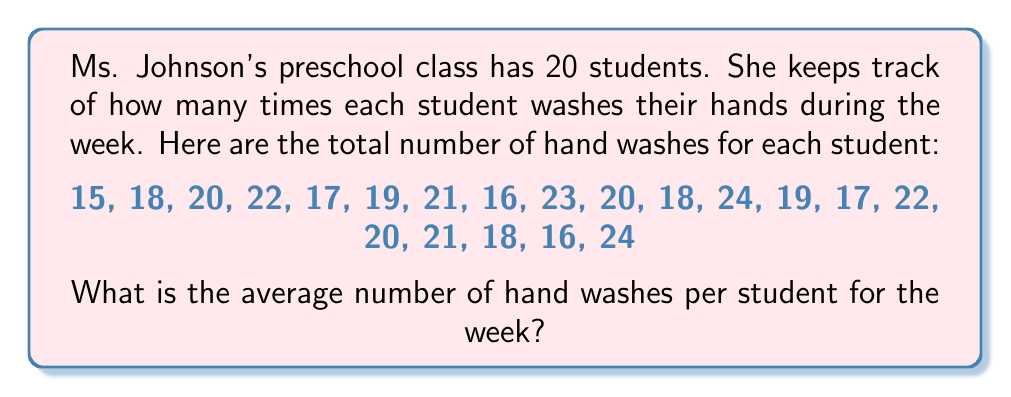Solve this math problem. To find the average number of hand washes per student, we need to follow these steps:

1. Add up all the hand washes:
   $15 + 18 + 20 + 22 + 17 + 19 + 21 + 16 + 23 + 20 + 18 + 24 + 19 + 17 + 22 + 20 + 21 + 18 + 16 + 24 = 390$

2. Count the total number of students:
   There are 20 students in the class.

3. Divide the total number of hand washes by the number of students:
   $$\text{Average} = \frac{\text{Sum of all hand washes}}{\text{Number of students}} = \frac{390}{20} = 19.5$$

Therefore, the average number of hand washes per student for the week is 19.5.
Answer: 19.5 hand washes per student 